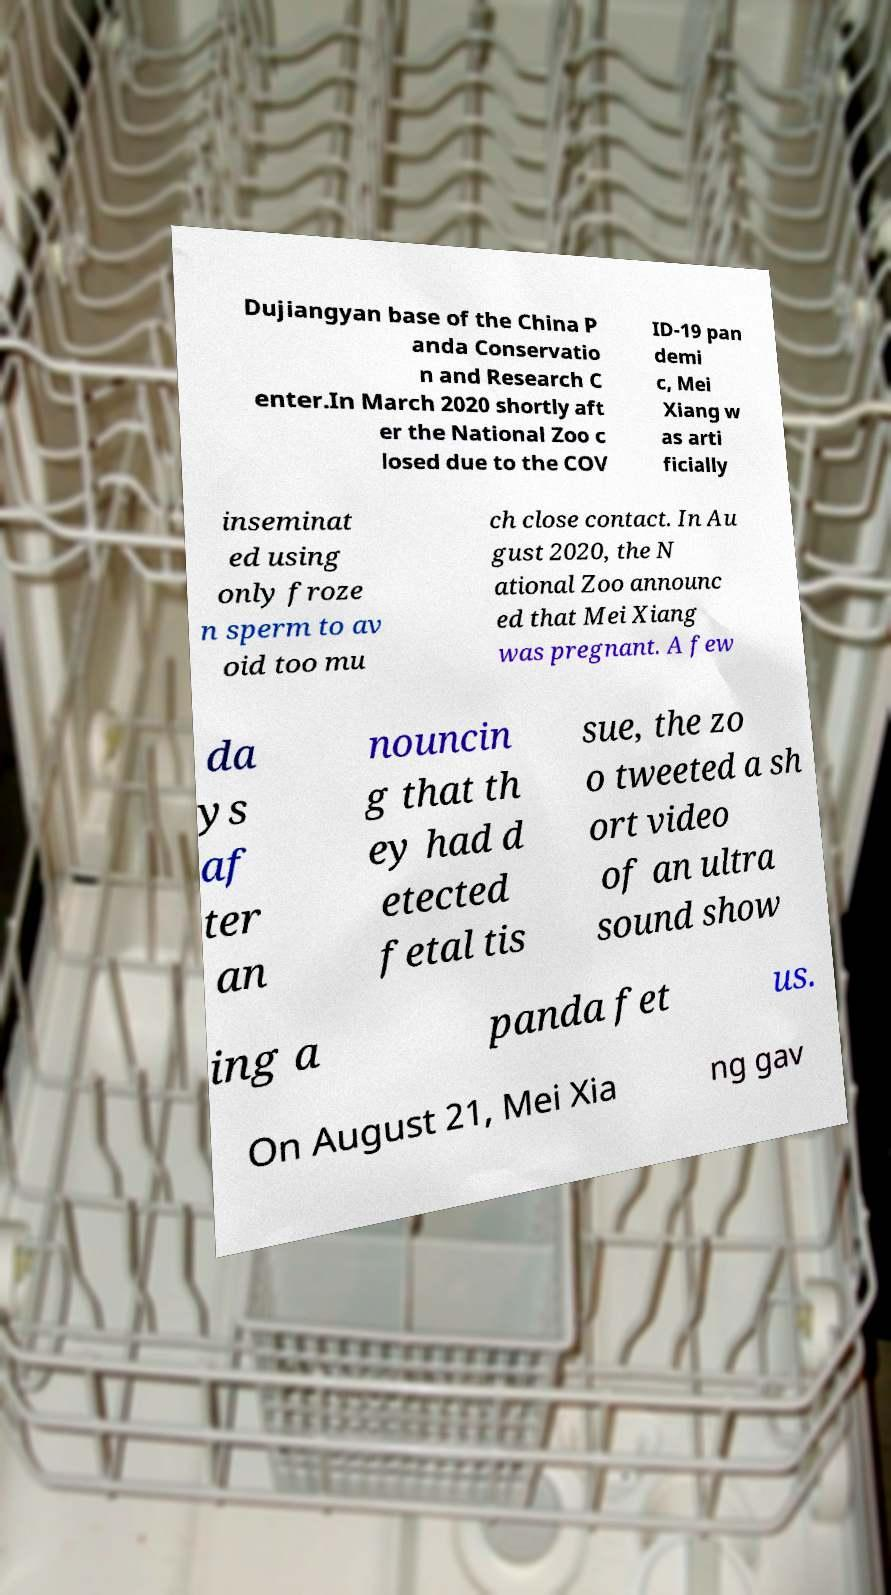Please identify and transcribe the text found in this image. Dujiangyan base of the China P anda Conservatio n and Research C enter.In March 2020 shortly aft er the National Zoo c losed due to the COV ID-19 pan demi c, Mei Xiang w as arti ficially inseminat ed using only froze n sperm to av oid too mu ch close contact. In Au gust 2020, the N ational Zoo announc ed that Mei Xiang was pregnant. A few da ys af ter an nouncin g that th ey had d etected fetal tis sue, the zo o tweeted a sh ort video of an ultra sound show ing a panda fet us. On August 21, Mei Xia ng gav 